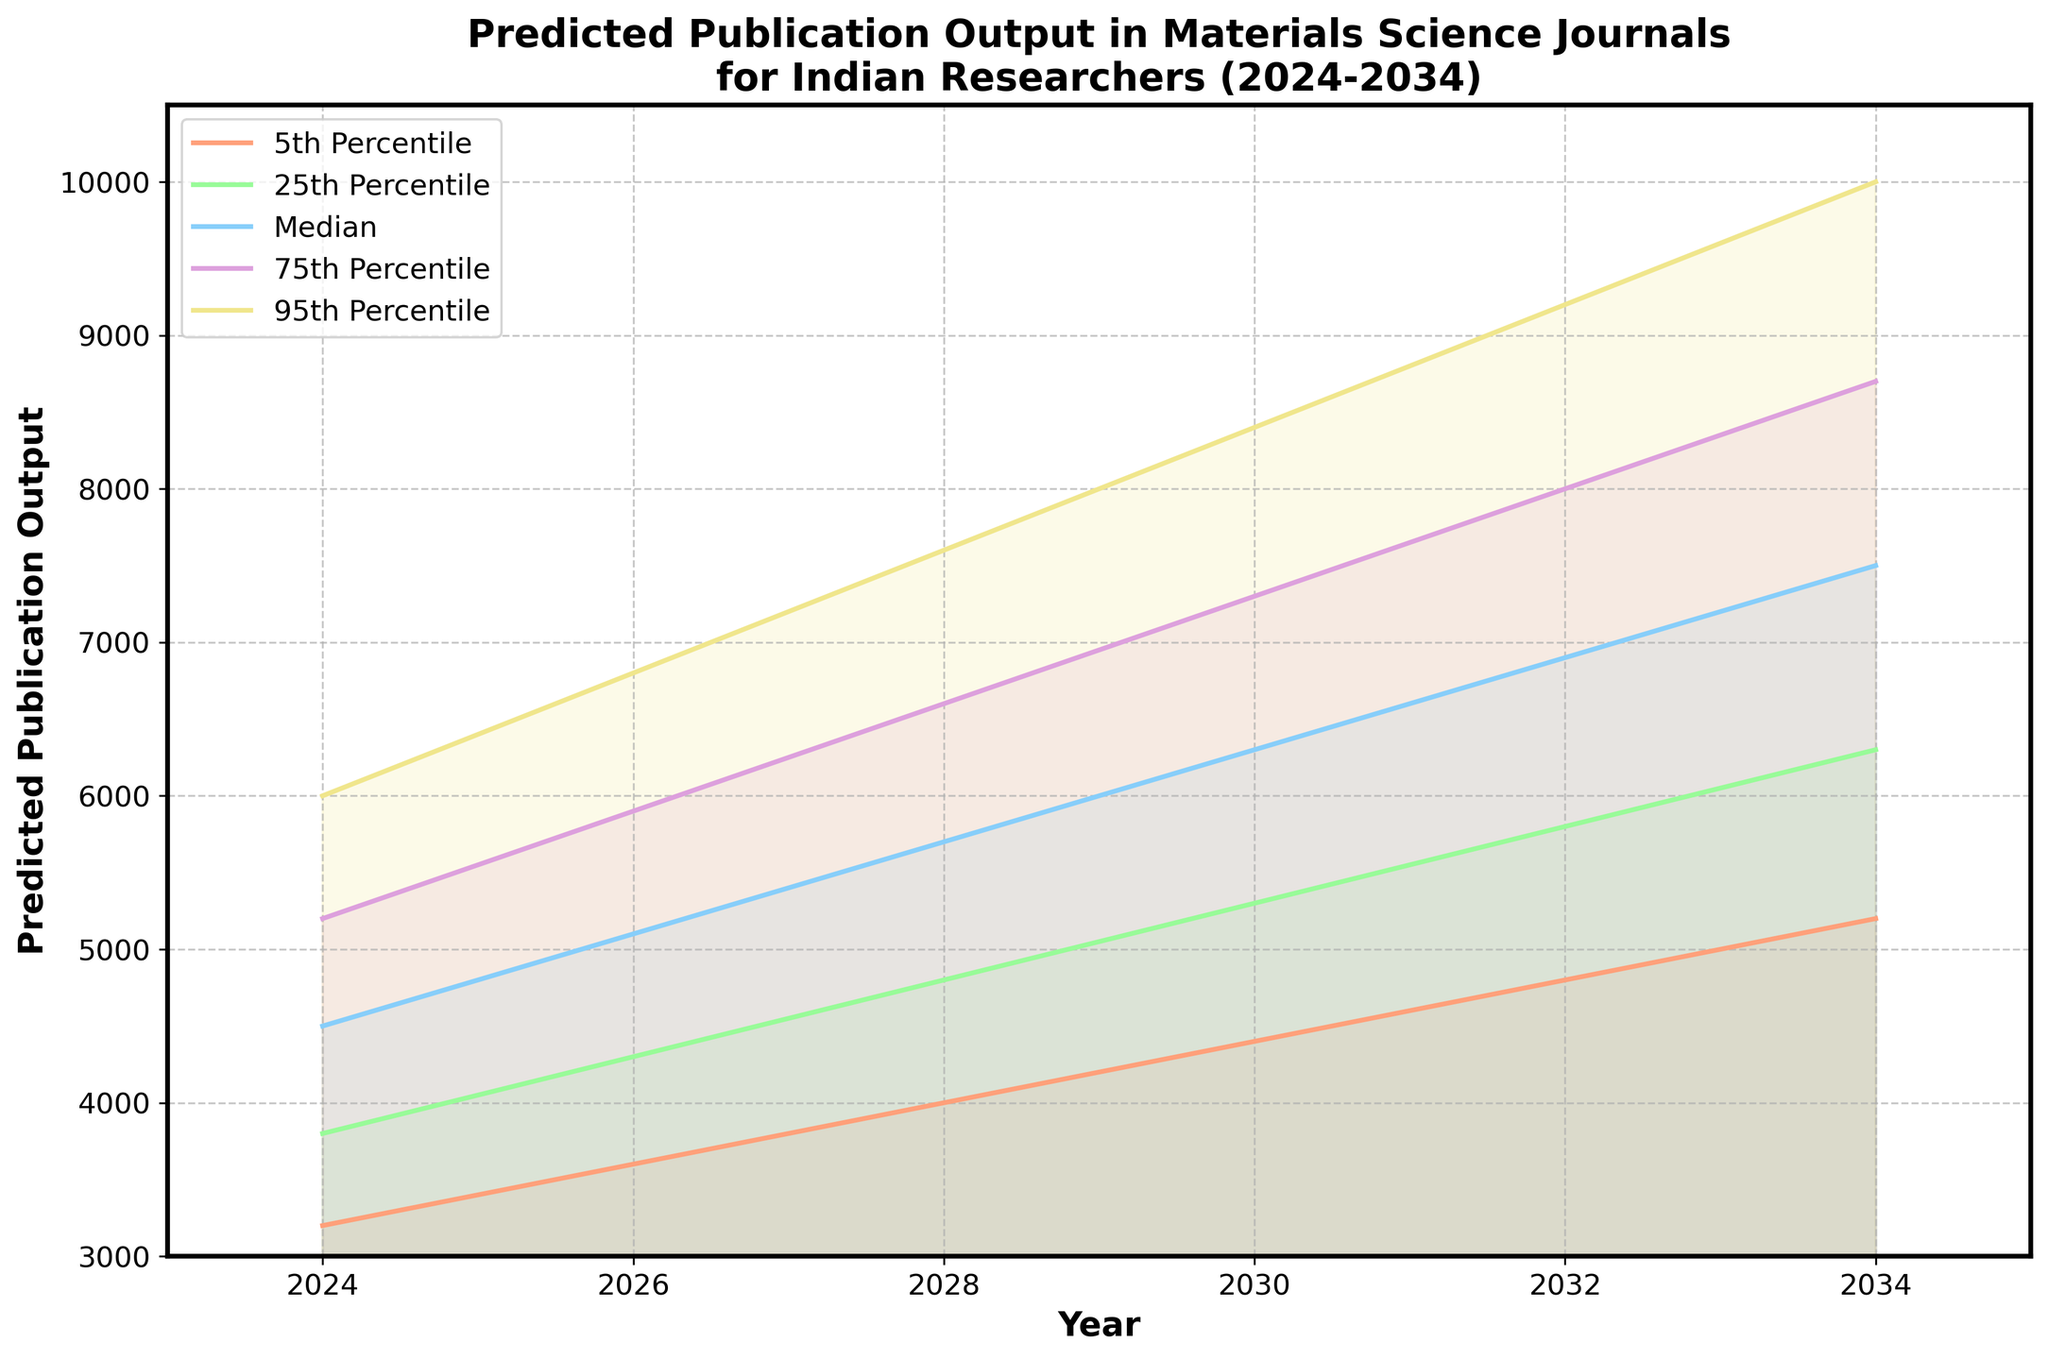What is the predicted median publication output in 2028? The median value for 2028 on the chart is shown as a central line within the shaded region. By looking at the chart, the median publication output for 2028 is depicted as 5700.
Answer: 5700 What is the range of predictions for publication output in 2032? The range can be determined by looking at the 5th and 95th percentile values for 2032. According to the chart, the 5th percentile is 4800 and the 95th percentile is 9200. So, the range is 9200 - 4800 = 4400.
Answer: 4400 By how much does the predicted median publication output increase from 2024 to 2034? To determine the increase, subtract the median value in 2024 from the median value in 2034. The median value in 2024 is 4500, and in 2034 it is 7500. Thus, the increase is 7500 - 4500 = 3000.
Answer: 3000 Which year shows the highest predicted 75th percentile value? By examining the chart, the highest 75th percentile value occurs in 2034, where it is 8700.
Answer: 2034 In what year does the predicted 5th percentile publication output cross 4000? By following the 5th percentile line across the chart, it crosses 4000 between 2026 and 2028. Since the precise year when it first crosses isn't clear between these years, it can be more accurately observed that it is above 4000 from 2028 onwards.
Answer: 2028 What is the average of the 5th percentile predictions for the years shown? To find the average, sum the 5th percentile values and divide by the number of years. The values are 3200, 3600, 4000, 4400, 4800, and 5200. Calculate (3200 + 3600 + 4000 + 4400 + 4800 + 5200) / 6. This equals 25200 / 6 = 4200.
Answer: 4200 In which year is the difference between the 95th and 5th percentiles the greatest? Calculate the differences for each year: 
2024: 6000 - 3200 = 2800,
2026: 6800 - 3600 = 3200,
2028: 7600 - 4000 = 3600,
2030: 8400 - 4400 = 4000,
2032: 9200 - 4800 = 4400,
2034: 10000 - 5200 = 4800. 
The largest difference is in 2034.
Answer: 2034 How does the predicted publication output for the 25th percentile in 2030 compare to the 75th percentile in 2026? According to the chart, the 25th percentile in 2030 is 5300, and the 75th percentile in 2026 is 5900. Thus, the 25th percentile in 2030 is less than the 75th percentile in 2026.
Answer: Less What does the fan shape represent in this chart? The fan shape is formed by the different percentile lines (5th, 25th, Median, 75th, and 95th), reflecting the range and distribution of predicted publication outputs over the decade. As time progresses, the range of uncertainty becomes wider, representing increased variability in predictions.
Answer: Range and distribution of predictions 